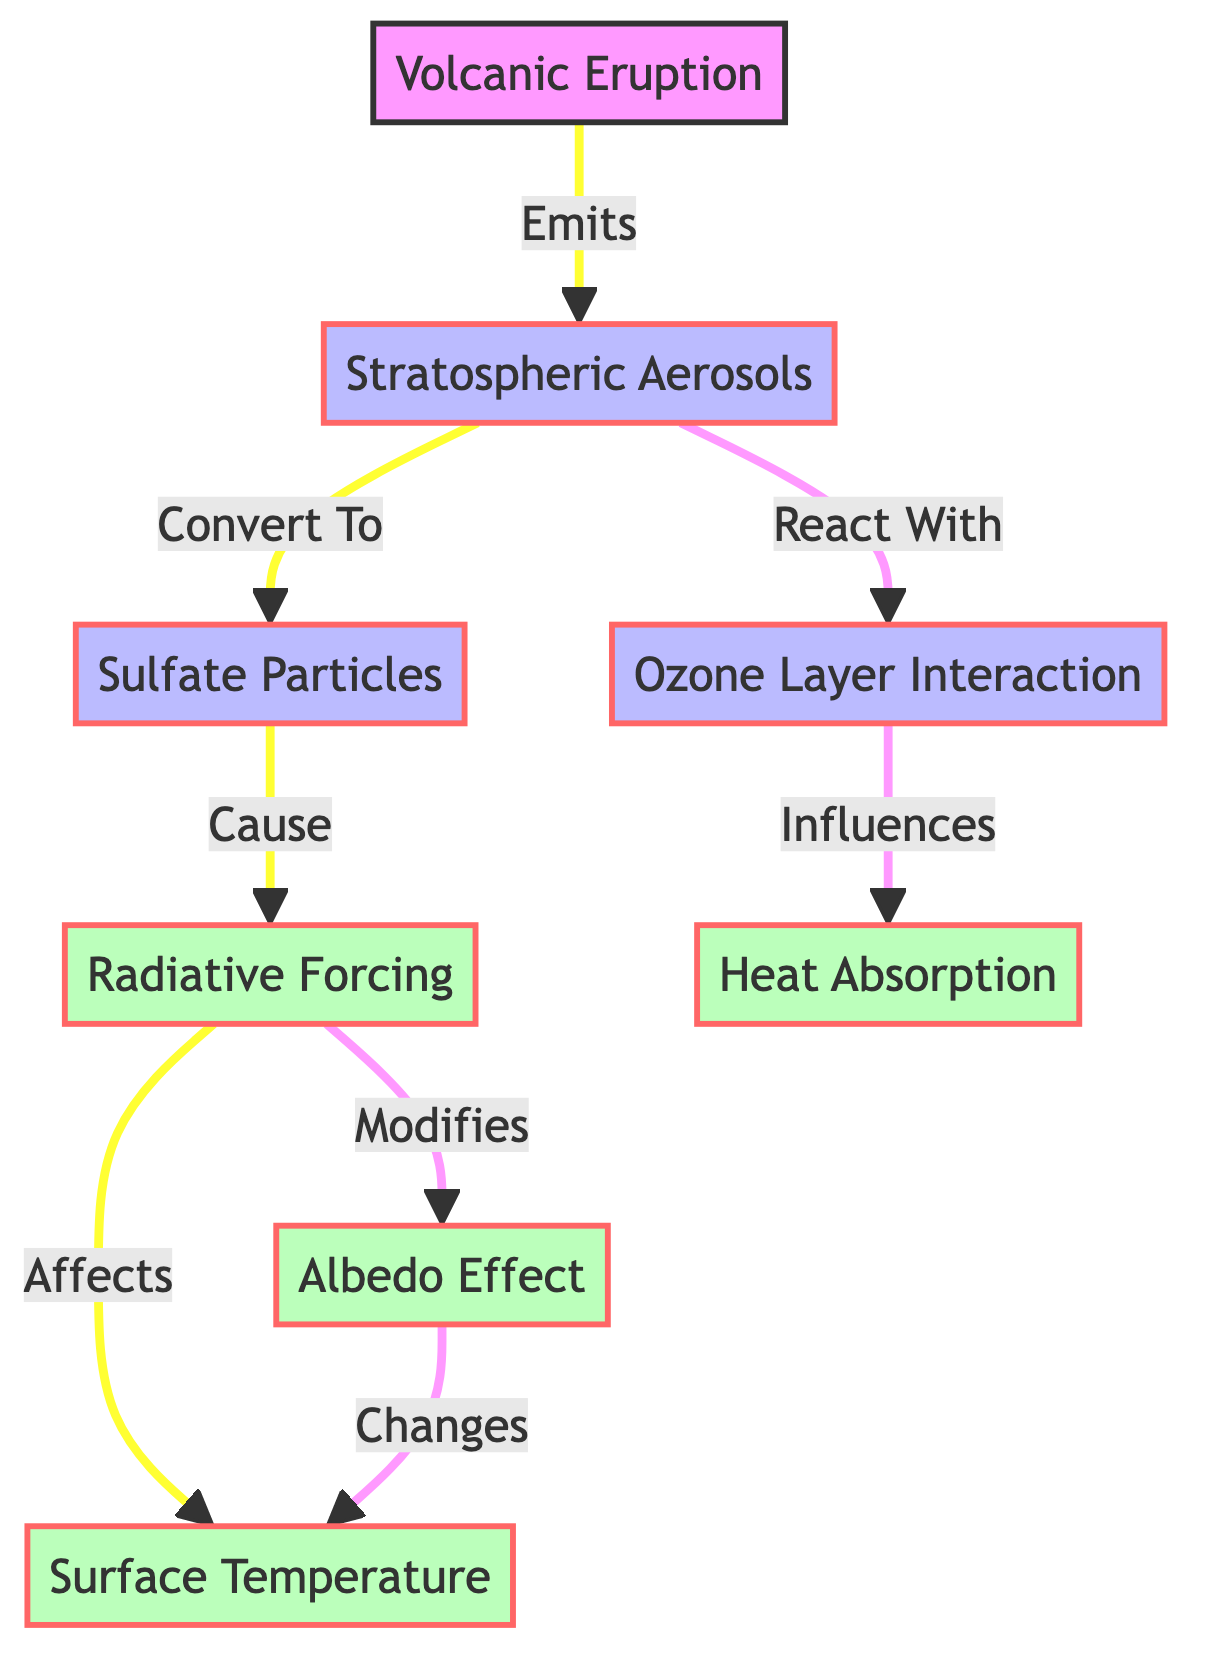What is the first node in the diagram? The first node is "Volcanic Eruption," which indicates the starting point of the process outlined in the diagram.
Answer: Volcanic Eruption How many processes are represented in the diagram? The diagram contains three process nodes: "Stratospheric Aerosols," "Sulfate Particles," and "Ozone Layer Interaction."
Answer: Three What does "Sulfate Particles" cause in the diagram? "Sulfate Particles" lead to "Radiative Forcing," as indicated by the arrow pointing from "Sulfate Particles" to "Radiative Forcing."
Answer: Radiative Forcing Which node is affected by both "Radiative Forcing" and "Albedo Effect"? The node "Surface Temperature" is affected by both "Radiative Forcing" (which modifies it) and "Albedo Effect" (which changes it), showing that it is influenced by multiple factors in the diagram.
Answer: Surface Temperature What effect does "Ozone Layer Interaction" have? "Ozone Layer Interaction" influences "Heat Absorption," as indicated by the directional flow connecting these two nodes.
Answer: Heat Absorption How does "Radiative Forcing" affect "Albedo Effect"? "Radiative Forcing" modifies the "Albedo Effect," which is represented in the diagram by the arrow linking these two nodes.
Answer: Modifies What is the relationship between "Stratospheric Aerosols" and "Ozone Layer Interaction"? "Stratospheric Aerosols" react with the "Ozone Layer Interaction," as shown by the arrow indicating this relationship.
Answer: React With How does "Albedo Effect" change "Surface Temperature"? "Albedo Effect" changes "Surface Temperature," which is indicated by the flow from "Albedo Effect" to "Surface Temperature."
Answer: Changes What is the last effect in the diagram? The last effect in the diagram is "Surface Temperature," which is the endpoint of the interactions represented in the diagram.
Answer: Surface Temperature 